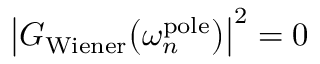Convert formula to latex. <formula><loc_0><loc_0><loc_500><loc_500>\left | G _ { W i e n e r } \left ( \omega _ { n } ^ { p o l e } \right ) \right | ^ { 2 } = 0</formula> 